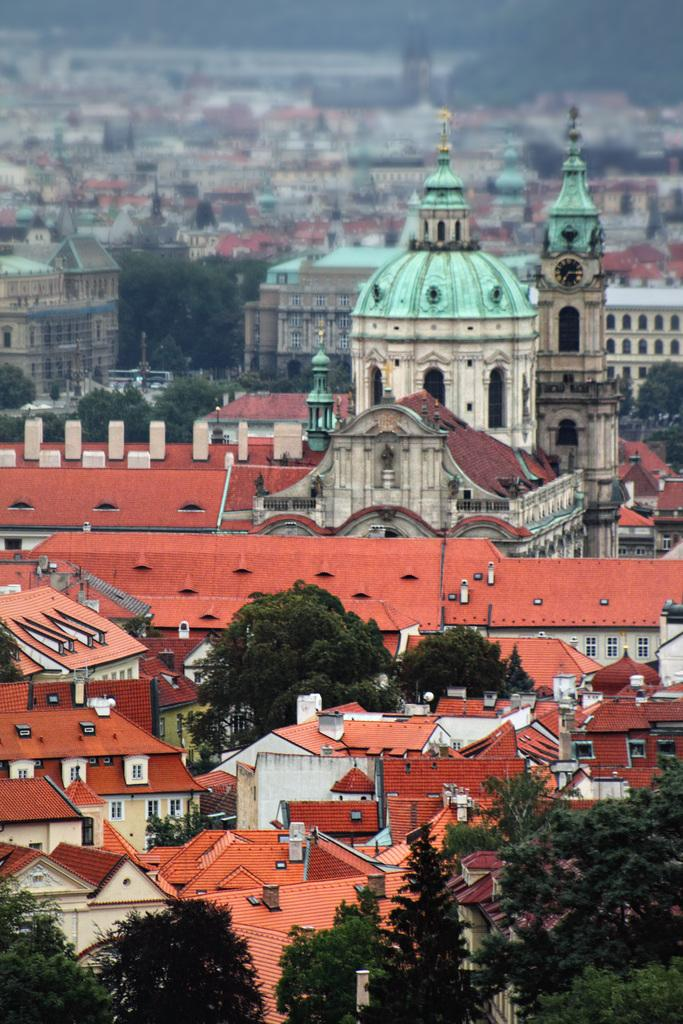What is the perspective of the image? The image shows a top view of a city. What types of structures can be seen in the image? There are many houses and buildings in the image. Are there any natural elements visible in the image? Yes, trees are present in the image. How many apples can be seen hanging from the trees in the image? There are no apples visible in the image; only trees are present. What type of curve can be seen in the image? There is no curve visible in the image; it is a top view of a city with straight lines and angles. 